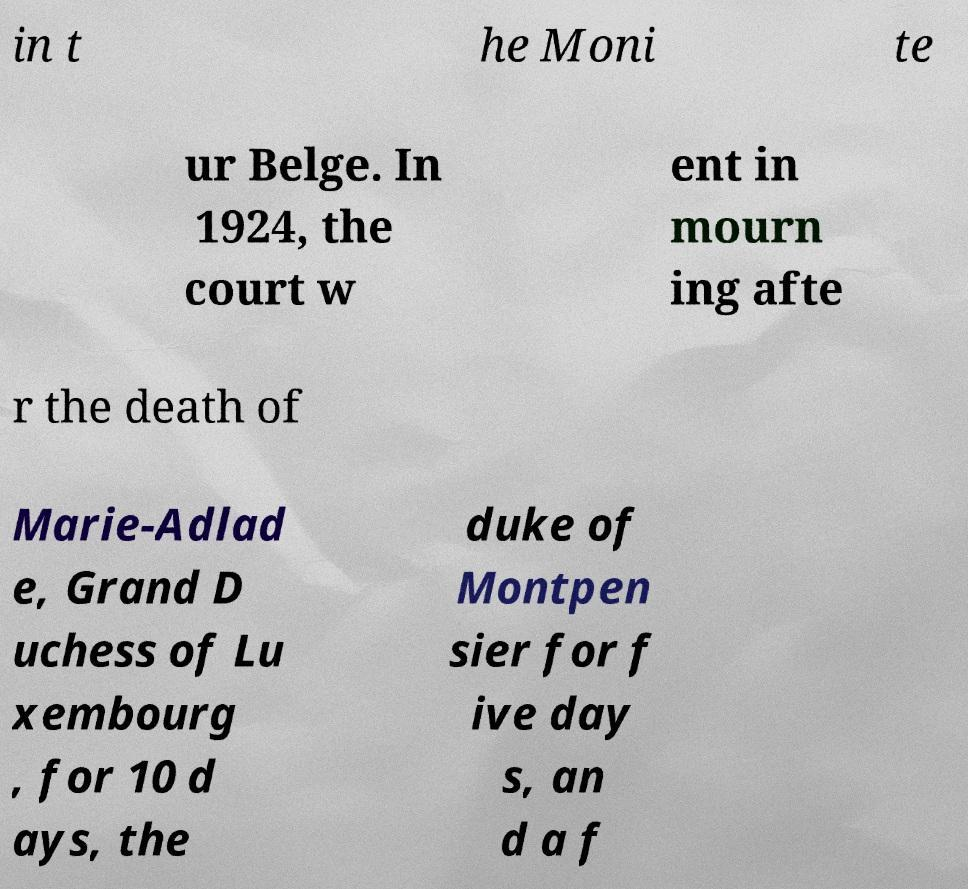Please read and relay the text visible in this image. What does it say? in t he Moni te ur Belge. In 1924, the court w ent in mourn ing afte r the death of Marie-Adlad e, Grand D uchess of Lu xembourg , for 10 d ays, the duke of Montpen sier for f ive day s, an d a f 